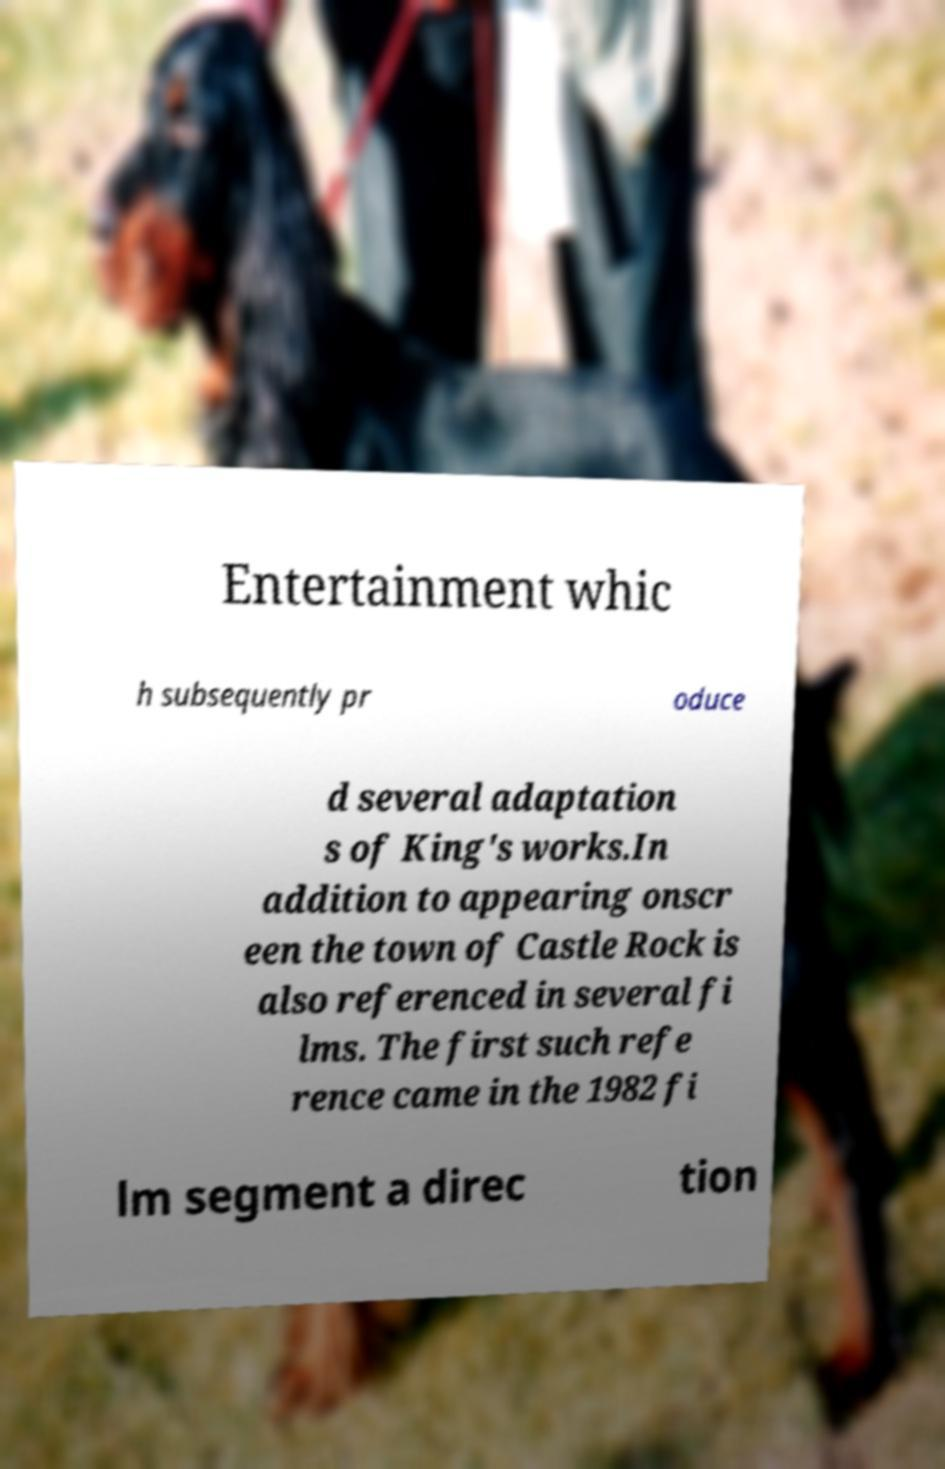Can you read and provide the text displayed in the image?This photo seems to have some interesting text. Can you extract and type it out for me? Entertainment whic h subsequently pr oduce d several adaptation s of King's works.In addition to appearing onscr een the town of Castle Rock is also referenced in several fi lms. The first such refe rence came in the 1982 fi lm segment a direc tion 